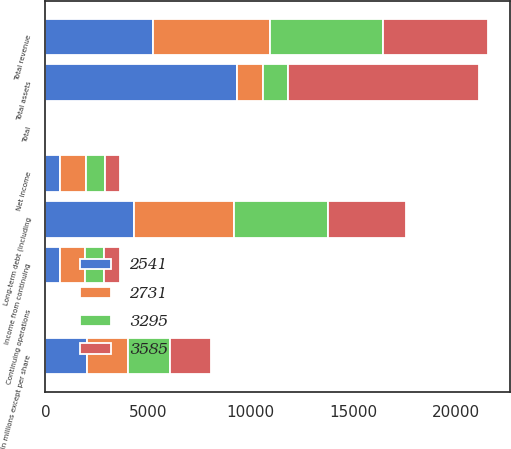Convert chart to OTSL. <chart><loc_0><loc_0><loc_500><loc_500><stacked_bar_chart><ecel><fcel>(In millions except per share<fcel>Total revenue<fcel>Income from continuing<fcel>Net income<fcel>Continuing operations<fcel>Total<fcel>Total assets<fcel>Long-term debt (including<nl><fcel>2731<fcel>2017<fcel>5696<fcel>1232<fcel>1246<fcel>5.84<fcel>5.9<fcel>1239<fcel>4900<nl><fcel>3295<fcel>2016<fcel>5505<fcel>930<fcel>930<fcel>4.22<fcel>4.22<fcel>1239<fcel>4562<nl><fcel>2541<fcel>2015<fcel>5254<fcel>712<fcel>712<fcel>3.04<fcel>3.04<fcel>9340<fcel>4293<nl><fcel>3585<fcel>2014<fcel>5066<fcel>754<fcel>754<fcel>3.04<fcel>3.03<fcel>9308<fcel>3790<nl></chart> 